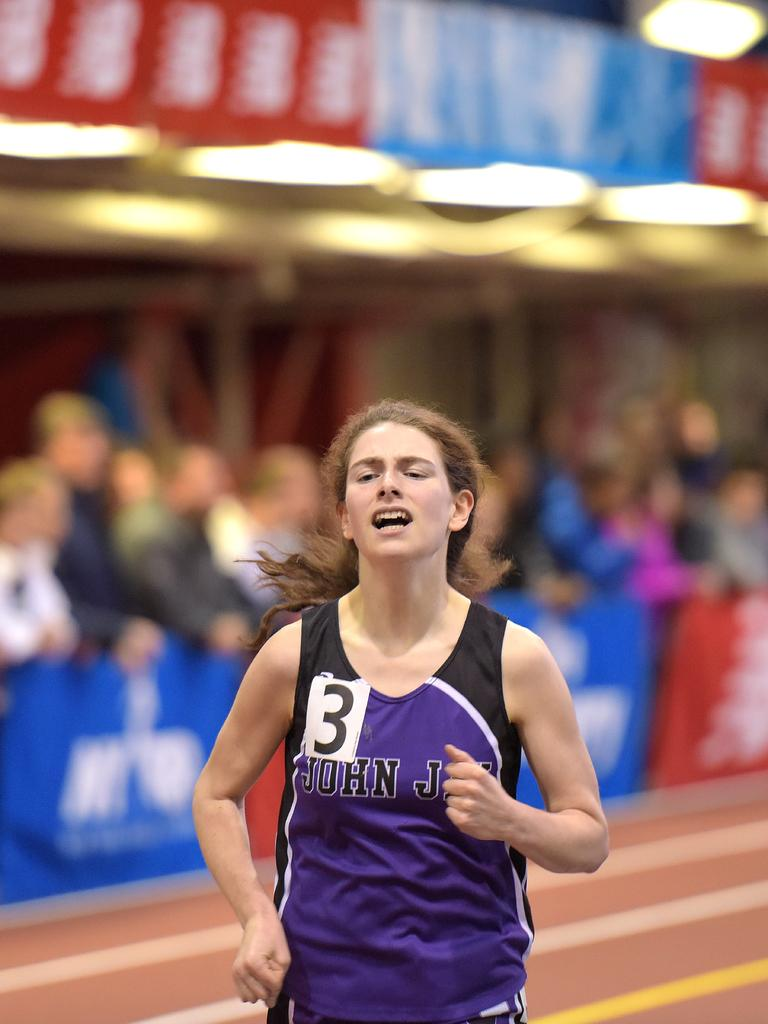<image>
Render a clear and concise summary of the photo. A female athlete's uniform contains the name John and the number 3. 